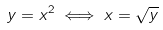Convert formula to latex. <formula><loc_0><loc_0><loc_500><loc_500>y = x ^ { 2 } \iff x = \sqrt { y }</formula> 